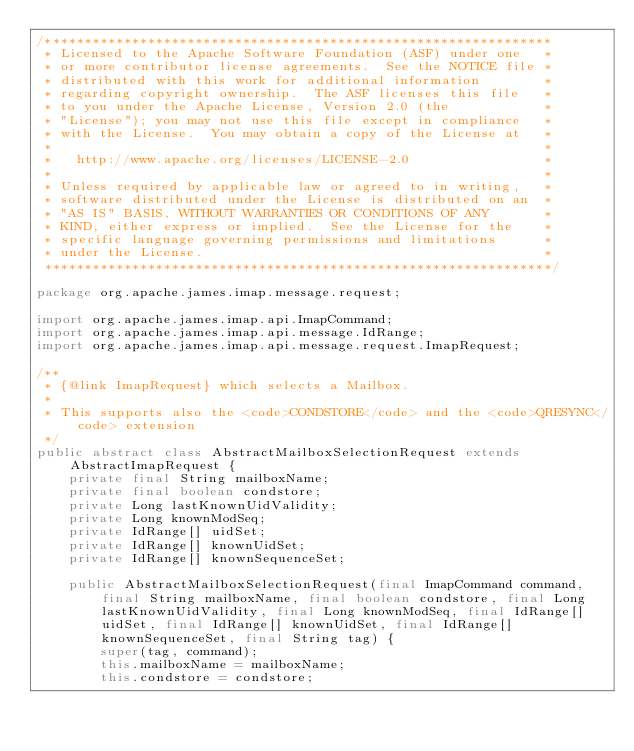Convert code to text. <code><loc_0><loc_0><loc_500><loc_500><_Java_>/****************************************************************
 * Licensed to the Apache Software Foundation (ASF) under one   *
 * or more contributor license agreements.  See the NOTICE file *
 * distributed with this work for additional information        *
 * regarding copyright ownership.  The ASF licenses this file   *
 * to you under the Apache License, Version 2.0 (the            *
 * "License"); you may not use this file except in compliance   *
 * with the License.  You may obtain a copy of the License at   *
 *                                                              *
 *   http://www.apache.org/licenses/LICENSE-2.0                 *
 *                                                              *
 * Unless required by applicable law or agreed to in writing,   *
 * software distributed under the License is distributed on an  *
 * "AS IS" BASIS, WITHOUT WARRANTIES OR CONDITIONS OF ANY       *
 * KIND, either express or implied.  See the License for the    *
 * specific language governing permissions and limitations      *
 * under the License.                                           *
 ****************************************************************/

package org.apache.james.imap.message.request;

import org.apache.james.imap.api.ImapCommand;
import org.apache.james.imap.api.message.IdRange;
import org.apache.james.imap.api.message.request.ImapRequest;

/**
 * {@link ImapRequest} which selects a Mailbox. 
 * 
 * This supports also the <code>CONDSTORE</code> and the <code>QRESYNC</code> extension
 */
public abstract class AbstractMailboxSelectionRequest extends AbstractImapRequest {
    private final String mailboxName;
    private final boolean condstore;
    private Long lastKnownUidValidity;
    private Long knownModSeq;
    private IdRange[] uidSet;
    private IdRange[] knownUidSet;
    private IdRange[] knownSequenceSet;

    public AbstractMailboxSelectionRequest(final ImapCommand command, final String mailboxName, final boolean condstore, final Long lastKnownUidValidity, final Long knownModSeq, final IdRange[] uidSet, final IdRange[] knownUidSet, final IdRange[] knownSequenceSet, final String tag) {
        super(tag, command);
        this.mailboxName = mailboxName;
        this.condstore = condstore;</code> 